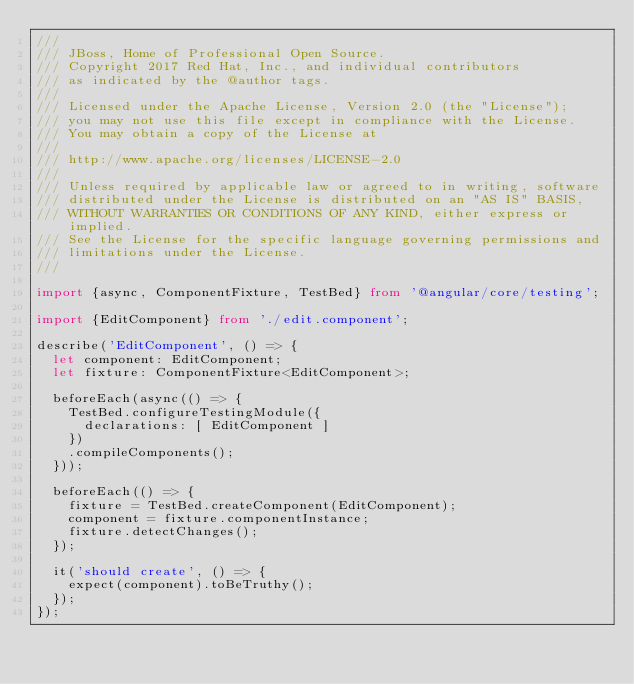Convert code to text. <code><loc_0><loc_0><loc_500><loc_500><_TypeScript_>///
/// JBoss, Home of Professional Open Source.
/// Copyright 2017 Red Hat, Inc., and individual contributors
/// as indicated by the @author tags.
///
/// Licensed under the Apache License, Version 2.0 (the "License");
/// you may not use this file except in compliance with the License.
/// You may obtain a copy of the License at
///
/// http://www.apache.org/licenses/LICENSE-2.0
///
/// Unless required by applicable law or agreed to in writing, software
/// distributed under the License is distributed on an "AS IS" BASIS,
/// WITHOUT WARRANTIES OR CONDITIONS OF ANY KIND, either express or implied.
/// See the License for the specific language governing permissions and
/// limitations under the License.
///

import {async, ComponentFixture, TestBed} from '@angular/core/testing';

import {EditComponent} from './edit.component';

describe('EditComponent', () => {
  let component: EditComponent;
  let fixture: ComponentFixture<EditComponent>;

  beforeEach(async(() => {
    TestBed.configureTestingModule({
      declarations: [ EditComponent ]
    })
    .compileComponents();
  }));

  beforeEach(() => {
    fixture = TestBed.createComponent(EditComponent);
    component = fixture.componentInstance;
    fixture.detectChanges();
  });

  it('should create', () => {
    expect(component).toBeTruthy();
  });
});
</code> 